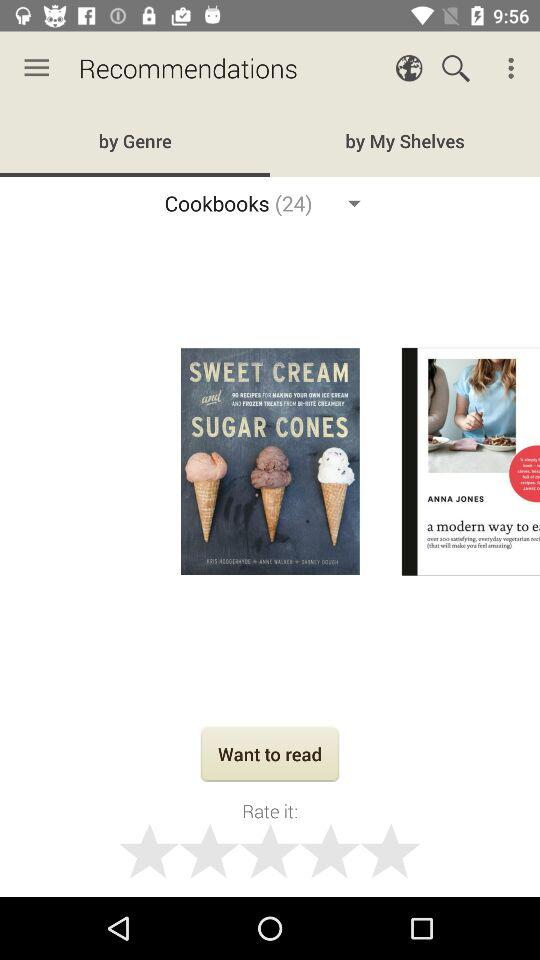Which tab is selected? The selected tab is "by Genre". 